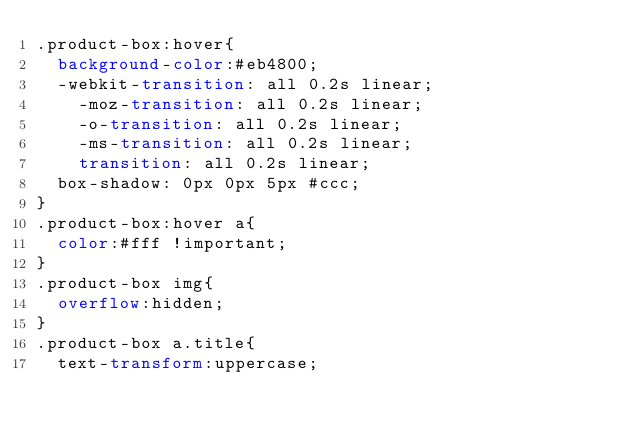<code> <loc_0><loc_0><loc_500><loc_500><_CSS_>.product-box:hover{
	background-color:#eb4800;
	-webkit-transition: all 0.2s linear;
    -moz-transition: all 0.2s linear;
    -o-transition: all 0.2s linear;
    -ms-transition: all 0.2s linear;
    transition: all 0.2s linear;
	box-shadow: 0px 0px 5px #ccc;
}
.product-box:hover a{
	color:#fff !important;
}
.product-box img{
	overflow:hidden;
}
.product-box a.title{
	text-transform:uppercase;</code> 